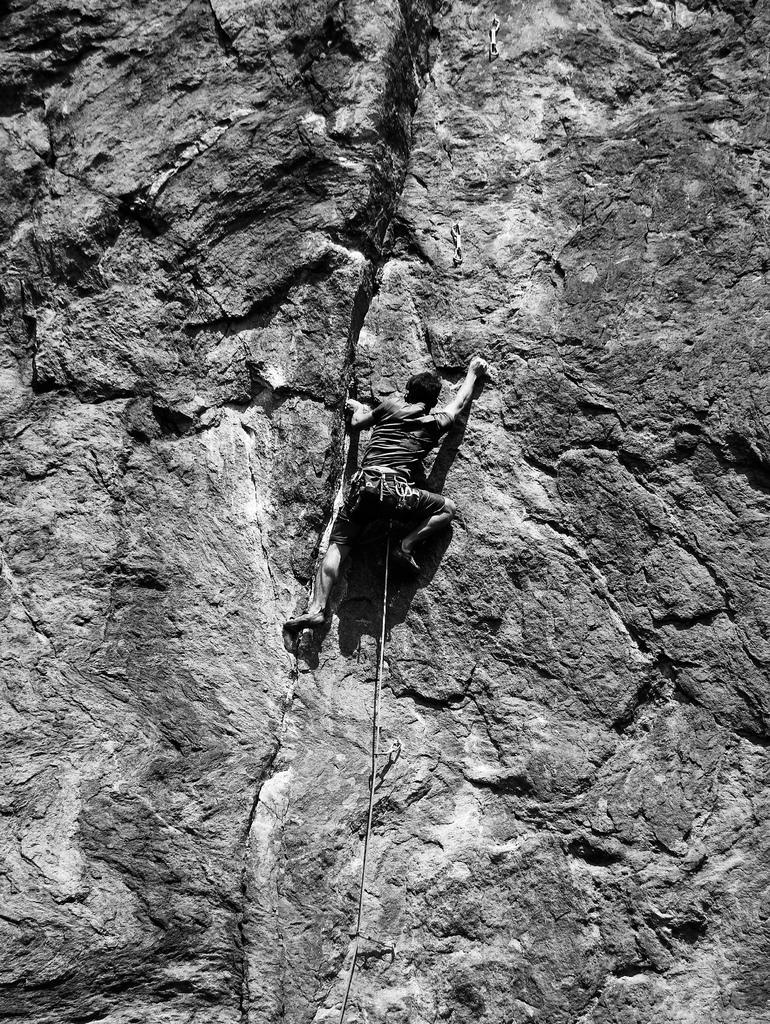Please provide a concise description of this image. This is the picture of a black and white image and we can see a person climbing the mountain. 